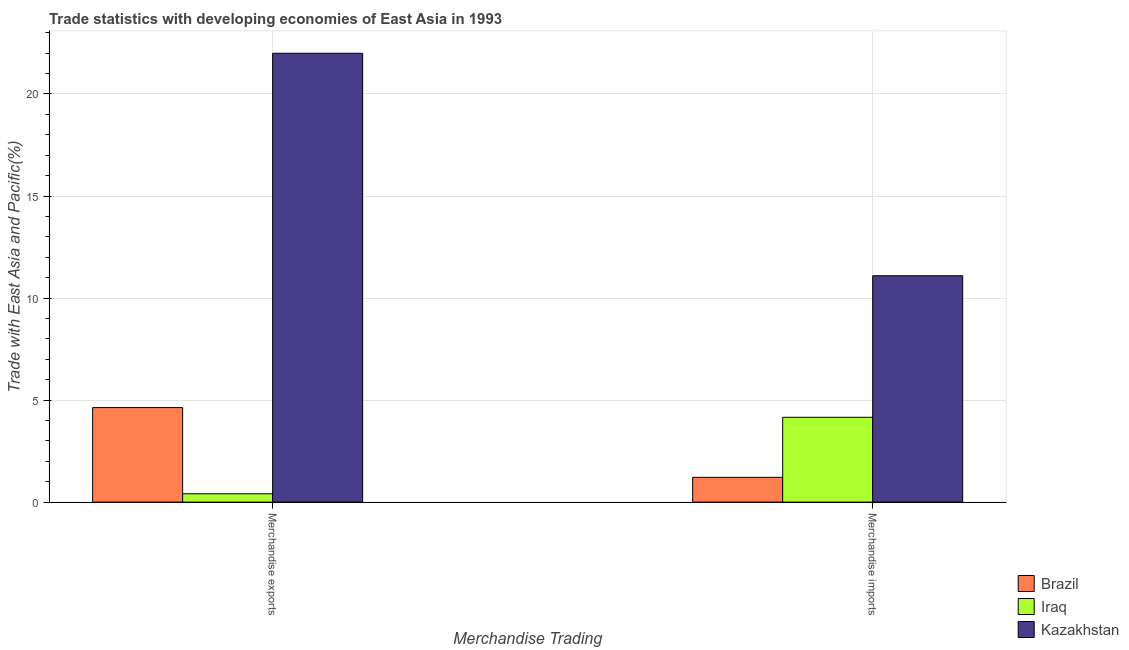How many different coloured bars are there?
Offer a very short reply. 3. How many groups of bars are there?
Provide a succinct answer. 2. How many bars are there on the 2nd tick from the right?
Keep it short and to the point. 3. What is the label of the 1st group of bars from the left?
Keep it short and to the point. Merchandise exports. What is the merchandise imports in Iraq?
Offer a very short reply. 4.16. Across all countries, what is the maximum merchandise exports?
Your answer should be very brief. 21.99. Across all countries, what is the minimum merchandise imports?
Offer a very short reply. 1.21. In which country was the merchandise imports maximum?
Ensure brevity in your answer.  Kazakhstan. In which country was the merchandise exports minimum?
Give a very brief answer. Iraq. What is the total merchandise exports in the graph?
Offer a very short reply. 27.04. What is the difference between the merchandise imports in Kazakhstan and that in Brazil?
Offer a terse response. 9.88. What is the difference between the merchandise imports in Brazil and the merchandise exports in Kazakhstan?
Provide a short and direct response. -20.78. What is the average merchandise imports per country?
Provide a succinct answer. 5.49. What is the difference between the merchandise exports and merchandise imports in Iraq?
Offer a terse response. -3.75. In how many countries, is the merchandise exports greater than 3 %?
Your answer should be compact. 2. What is the ratio of the merchandise imports in Brazil to that in Kazakhstan?
Offer a very short reply. 0.11. Is the merchandise exports in Iraq less than that in Brazil?
Offer a very short reply. Yes. What does the 3rd bar from the left in Merchandise exports represents?
Your response must be concise. Kazakhstan. What does the 3rd bar from the right in Merchandise imports represents?
Offer a very short reply. Brazil. How many bars are there?
Provide a succinct answer. 6. What is the difference between two consecutive major ticks on the Y-axis?
Make the answer very short. 5. Where does the legend appear in the graph?
Ensure brevity in your answer.  Bottom right. What is the title of the graph?
Give a very brief answer. Trade statistics with developing economies of East Asia in 1993. What is the label or title of the X-axis?
Provide a succinct answer. Merchandise Trading. What is the label or title of the Y-axis?
Provide a succinct answer. Trade with East Asia and Pacific(%). What is the Trade with East Asia and Pacific(%) of Brazil in Merchandise exports?
Offer a terse response. 4.63. What is the Trade with East Asia and Pacific(%) in Iraq in Merchandise exports?
Your answer should be compact. 0.41. What is the Trade with East Asia and Pacific(%) of Kazakhstan in Merchandise exports?
Offer a terse response. 21.99. What is the Trade with East Asia and Pacific(%) in Brazil in Merchandise imports?
Your response must be concise. 1.21. What is the Trade with East Asia and Pacific(%) of Iraq in Merchandise imports?
Give a very brief answer. 4.16. What is the Trade with East Asia and Pacific(%) of Kazakhstan in Merchandise imports?
Ensure brevity in your answer.  11.09. Across all Merchandise Trading, what is the maximum Trade with East Asia and Pacific(%) in Brazil?
Offer a terse response. 4.63. Across all Merchandise Trading, what is the maximum Trade with East Asia and Pacific(%) of Iraq?
Provide a short and direct response. 4.16. Across all Merchandise Trading, what is the maximum Trade with East Asia and Pacific(%) in Kazakhstan?
Offer a terse response. 21.99. Across all Merchandise Trading, what is the minimum Trade with East Asia and Pacific(%) of Brazil?
Ensure brevity in your answer.  1.21. Across all Merchandise Trading, what is the minimum Trade with East Asia and Pacific(%) in Iraq?
Give a very brief answer. 0.41. Across all Merchandise Trading, what is the minimum Trade with East Asia and Pacific(%) of Kazakhstan?
Offer a very short reply. 11.09. What is the total Trade with East Asia and Pacific(%) in Brazil in the graph?
Keep it short and to the point. 5.85. What is the total Trade with East Asia and Pacific(%) of Iraq in the graph?
Your answer should be compact. 4.57. What is the total Trade with East Asia and Pacific(%) in Kazakhstan in the graph?
Ensure brevity in your answer.  33.09. What is the difference between the Trade with East Asia and Pacific(%) in Brazil in Merchandise exports and that in Merchandise imports?
Ensure brevity in your answer.  3.42. What is the difference between the Trade with East Asia and Pacific(%) in Iraq in Merchandise exports and that in Merchandise imports?
Your answer should be compact. -3.75. What is the difference between the Trade with East Asia and Pacific(%) of Kazakhstan in Merchandise exports and that in Merchandise imports?
Your answer should be very brief. 10.9. What is the difference between the Trade with East Asia and Pacific(%) in Brazil in Merchandise exports and the Trade with East Asia and Pacific(%) in Iraq in Merchandise imports?
Provide a succinct answer. 0.48. What is the difference between the Trade with East Asia and Pacific(%) of Brazil in Merchandise exports and the Trade with East Asia and Pacific(%) of Kazakhstan in Merchandise imports?
Offer a very short reply. -6.46. What is the difference between the Trade with East Asia and Pacific(%) in Iraq in Merchandise exports and the Trade with East Asia and Pacific(%) in Kazakhstan in Merchandise imports?
Your response must be concise. -10.68. What is the average Trade with East Asia and Pacific(%) in Brazil per Merchandise Trading?
Offer a terse response. 2.92. What is the average Trade with East Asia and Pacific(%) of Iraq per Merchandise Trading?
Provide a short and direct response. 2.28. What is the average Trade with East Asia and Pacific(%) of Kazakhstan per Merchandise Trading?
Ensure brevity in your answer.  16.54. What is the difference between the Trade with East Asia and Pacific(%) of Brazil and Trade with East Asia and Pacific(%) of Iraq in Merchandise exports?
Your answer should be very brief. 4.22. What is the difference between the Trade with East Asia and Pacific(%) of Brazil and Trade with East Asia and Pacific(%) of Kazakhstan in Merchandise exports?
Keep it short and to the point. -17.36. What is the difference between the Trade with East Asia and Pacific(%) in Iraq and Trade with East Asia and Pacific(%) in Kazakhstan in Merchandise exports?
Give a very brief answer. -21.58. What is the difference between the Trade with East Asia and Pacific(%) of Brazil and Trade with East Asia and Pacific(%) of Iraq in Merchandise imports?
Your answer should be compact. -2.94. What is the difference between the Trade with East Asia and Pacific(%) in Brazil and Trade with East Asia and Pacific(%) in Kazakhstan in Merchandise imports?
Offer a terse response. -9.88. What is the difference between the Trade with East Asia and Pacific(%) in Iraq and Trade with East Asia and Pacific(%) in Kazakhstan in Merchandise imports?
Your answer should be compact. -6.94. What is the ratio of the Trade with East Asia and Pacific(%) of Brazil in Merchandise exports to that in Merchandise imports?
Your answer should be very brief. 3.81. What is the ratio of the Trade with East Asia and Pacific(%) in Iraq in Merchandise exports to that in Merchandise imports?
Ensure brevity in your answer.  0.1. What is the ratio of the Trade with East Asia and Pacific(%) in Kazakhstan in Merchandise exports to that in Merchandise imports?
Offer a terse response. 1.98. What is the difference between the highest and the second highest Trade with East Asia and Pacific(%) of Brazil?
Offer a terse response. 3.42. What is the difference between the highest and the second highest Trade with East Asia and Pacific(%) in Iraq?
Ensure brevity in your answer.  3.75. What is the difference between the highest and the second highest Trade with East Asia and Pacific(%) in Kazakhstan?
Offer a very short reply. 10.9. What is the difference between the highest and the lowest Trade with East Asia and Pacific(%) in Brazil?
Provide a short and direct response. 3.42. What is the difference between the highest and the lowest Trade with East Asia and Pacific(%) in Iraq?
Your answer should be very brief. 3.75. What is the difference between the highest and the lowest Trade with East Asia and Pacific(%) of Kazakhstan?
Keep it short and to the point. 10.9. 